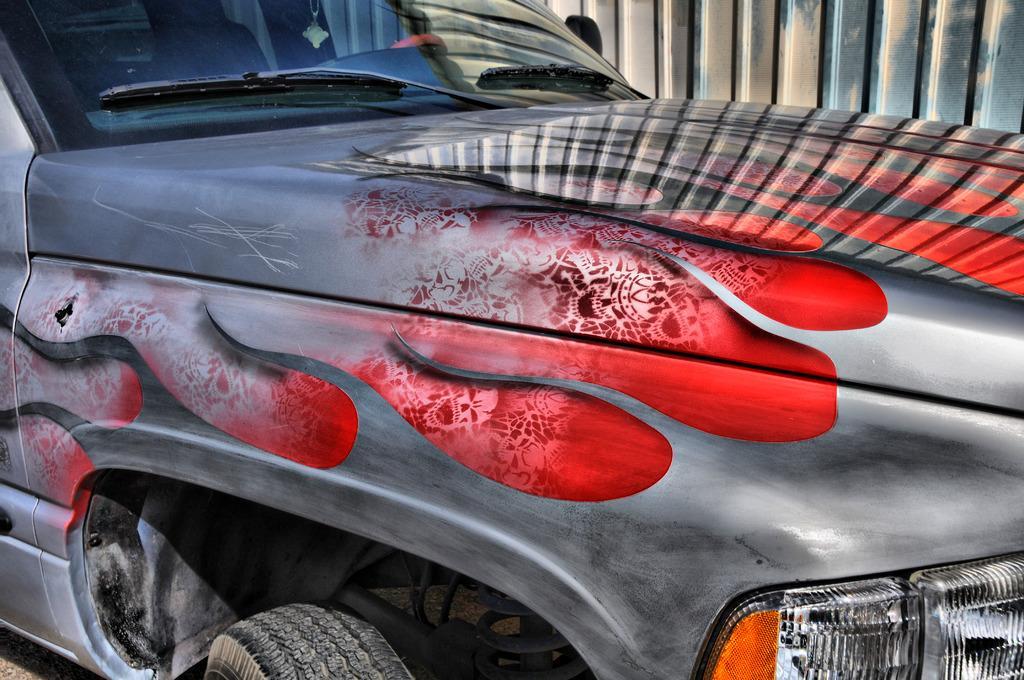Could you give a brief overview of what you see in this image? In this image we can see a car with some sticker on it. In the background of the image there is wall. 